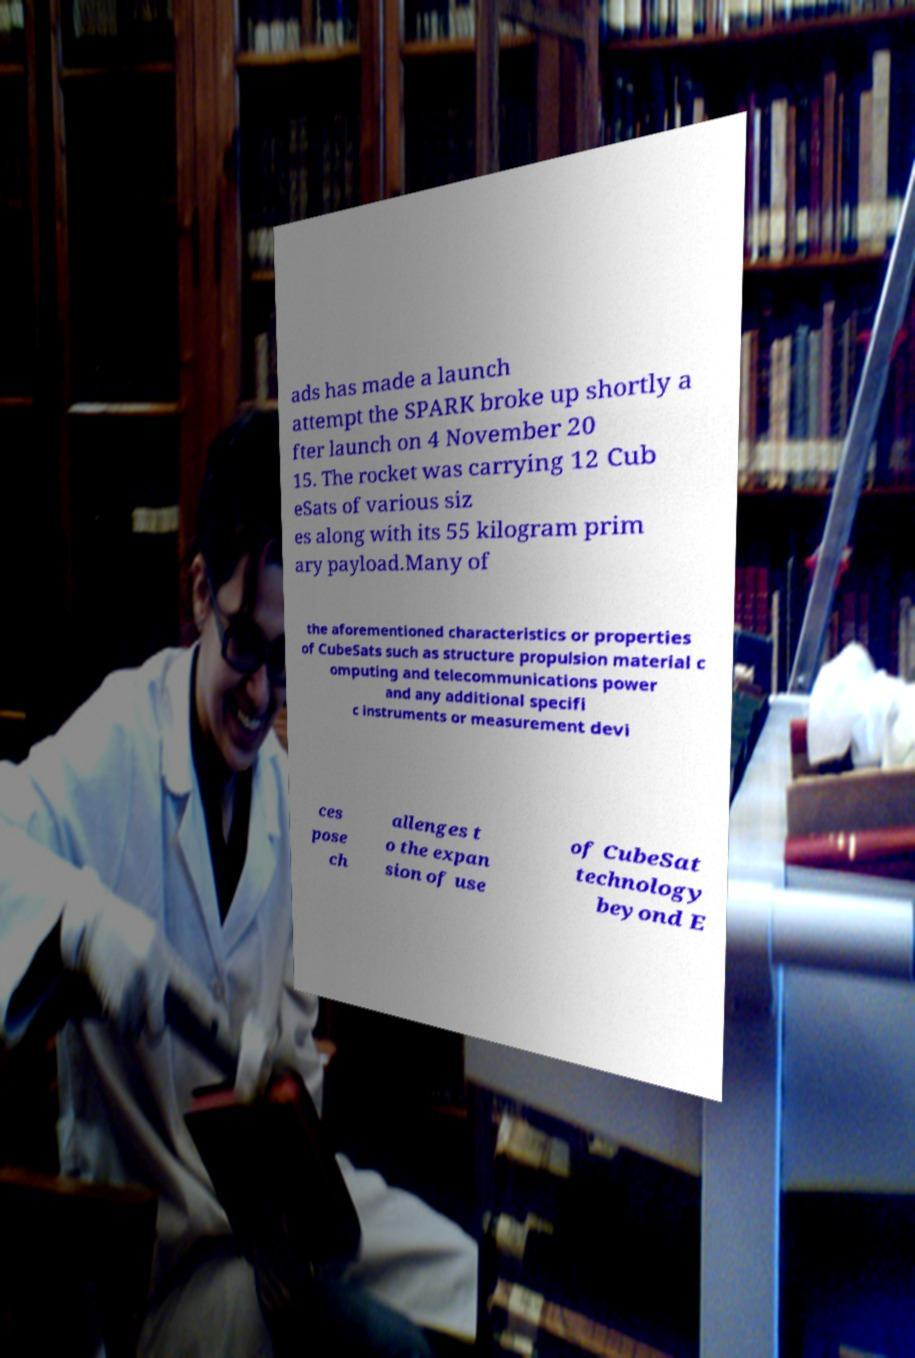Please read and relay the text visible in this image. What does it say? ads has made a launch attempt the SPARK broke up shortly a fter launch on 4 November 20 15. The rocket was carrying 12 Cub eSats of various siz es along with its 55 kilogram prim ary payload.Many of the aforementioned characteristics or properties of CubeSats such as structure propulsion material c omputing and telecommunications power and any additional specifi c instruments or measurement devi ces pose ch allenges t o the expan sion of use of CubeSat technology beyond E 